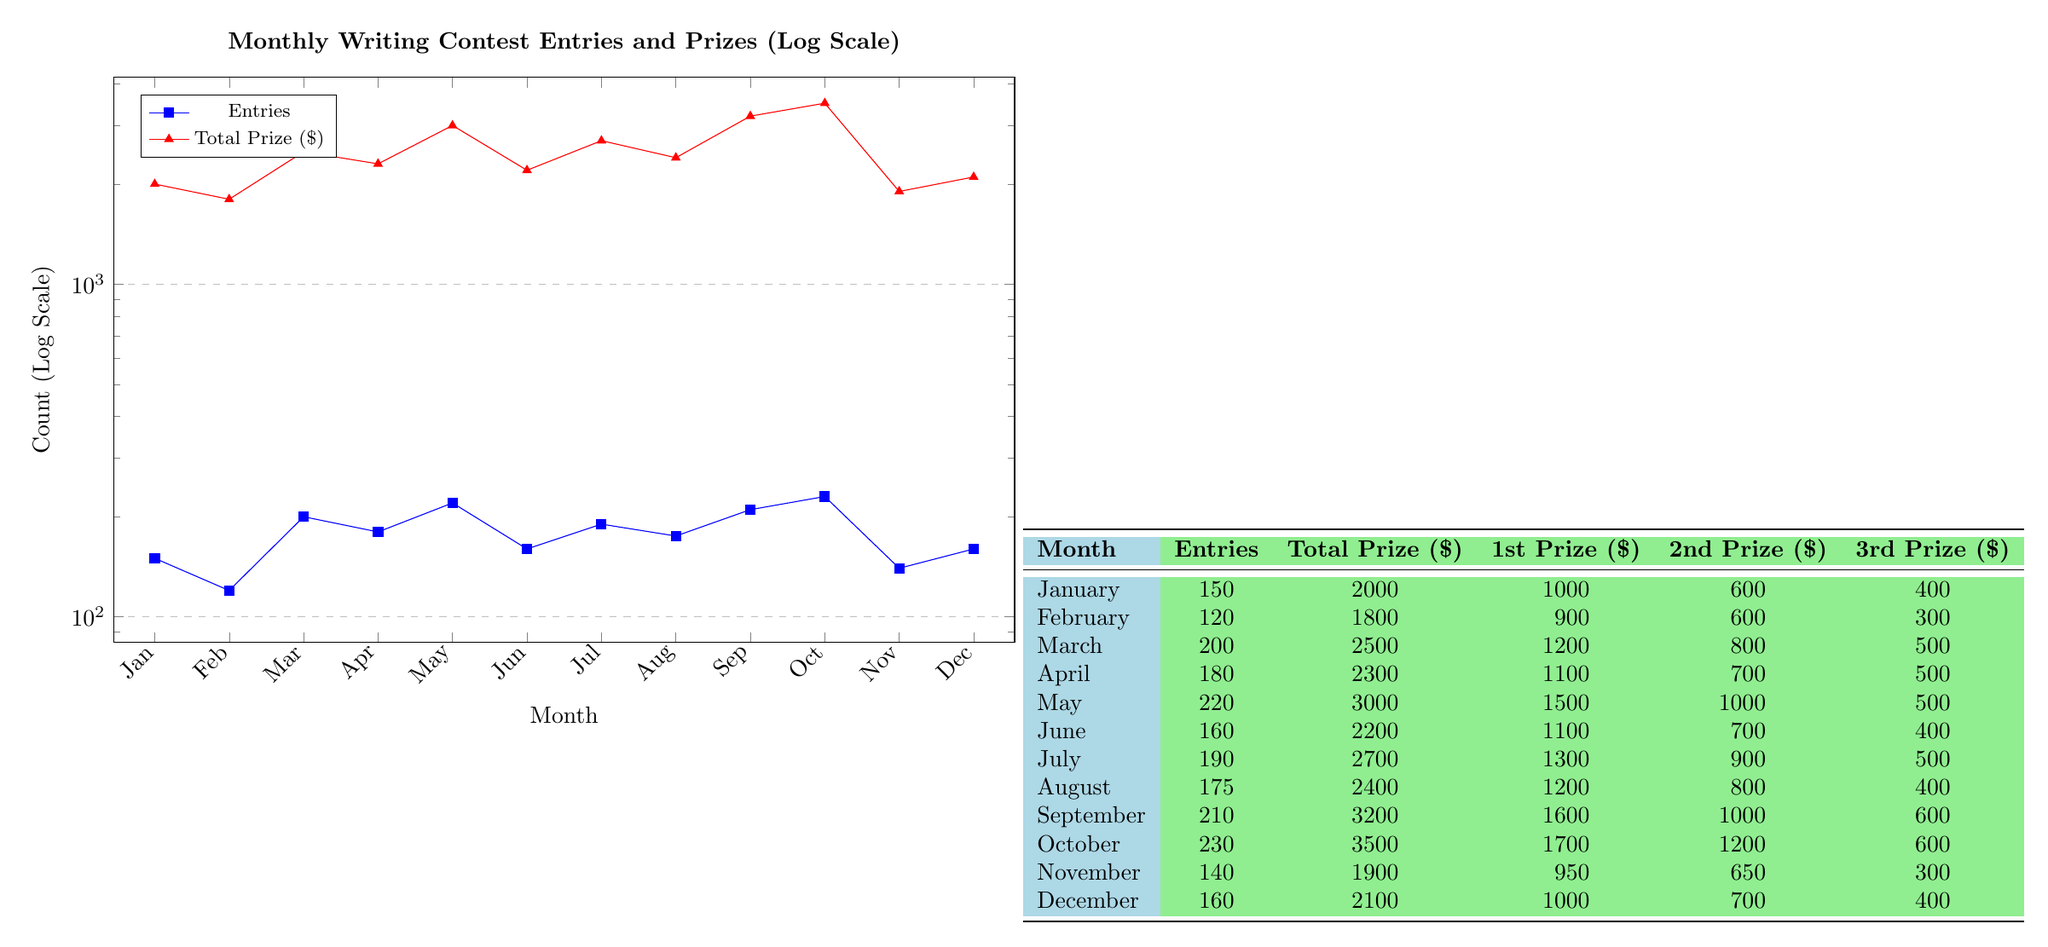What was the total prize amount in May? According to the table, in May, the total prize amount is listed as 3000.
Answer: 3000 How many entries were received in December? The table shows that December had 160 entries.
Answer: 160 Which month had the highest first prize amount and what was it? From the table, October has the highest first prize amount of 1700.
Answer: 1700 What is the average number of entries from January to March? The number of entries in January is 150, in February is 120, and in March is 200. The average is calculated as (150 + 120 + 200) / 3 = 470 / 3 ≈ 156.67, rounded to 157.
Answer: 157 Is the total prize amount in April greater than that in November? Looking at the table, the total prize amount in April is 2300, and in November it is 1900. Since 2300 is greater than 1900, the answer is yes.
Answer: Yes What is the difference in entries between October and February? The number of entries in October is 230 and in February is 120. The difference is calculated as 230 - 120 = 110.
Answer: 110 Which month showed a decrease in both entries and total prize amount compared to the previous month? By reviewing the entries and total prize amounts month by month, it's noticed that from September (210 entries and 3200 total prize) to October (230 entries and 3500 total prize) the amount increased. However, from November (140 entries and 1900 total prize) to December (160 entries and 2100 total prize) there was no decrease in total prize amount. Analyzing further, no month showed a decrease in both measurements over consecutive months.
Answer: No month How much total prize money was awarded in the month with the highest number of entries? The month with the highest number of entries is October with 230 entries, and the total prize amount for October is 3500, according to the table.
Answer: 3500 In which month was the second prize amount the highest and what was the amount? According to the table, the month with the highest second prize amount is October, which awarded 1200 for the second prize.
Answer: 1200 